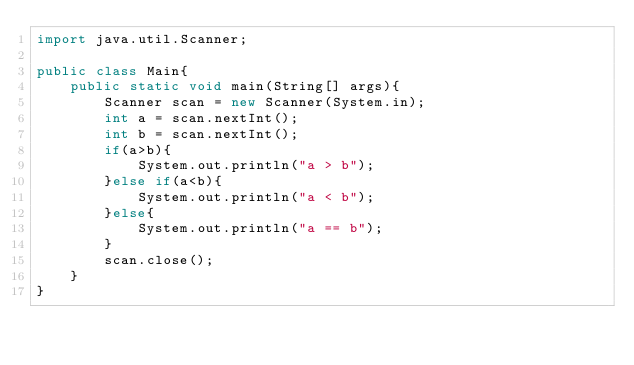Convert code to text. <code><loc_0><loc_0><loc_500><loc_500><_Java_>import java.util.Scanner;

public class Main{
    public static void main(String[] args){
        Scanner scan = new Scanner(System.in);
        int a = scan.nextInt();
        int b = scan.nextInt();
        if(a>b){
            System.out.println("a > b");
        }else if(a<b){
            System.out.println("a < b");
        }else{
            System.out.println("a == b");
        }
        scan.close();
    }
}
</code> 